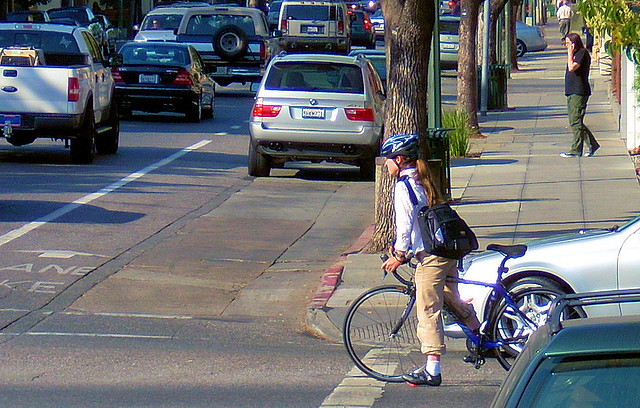Please identify all text content in this image. E ANE 